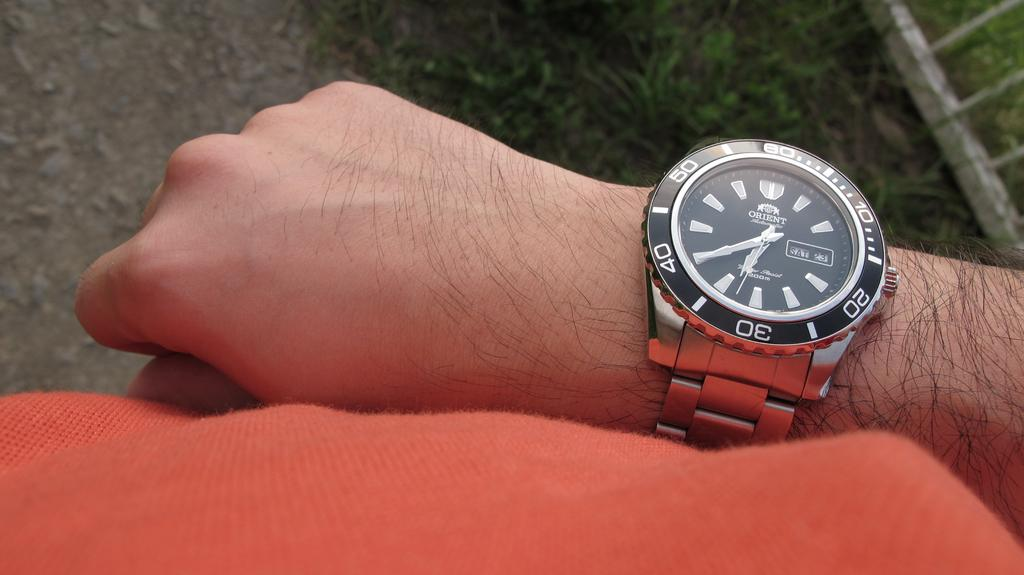Provide a one-sentence caption for the provided image. An Orient brand watch says that today is Saturday. 